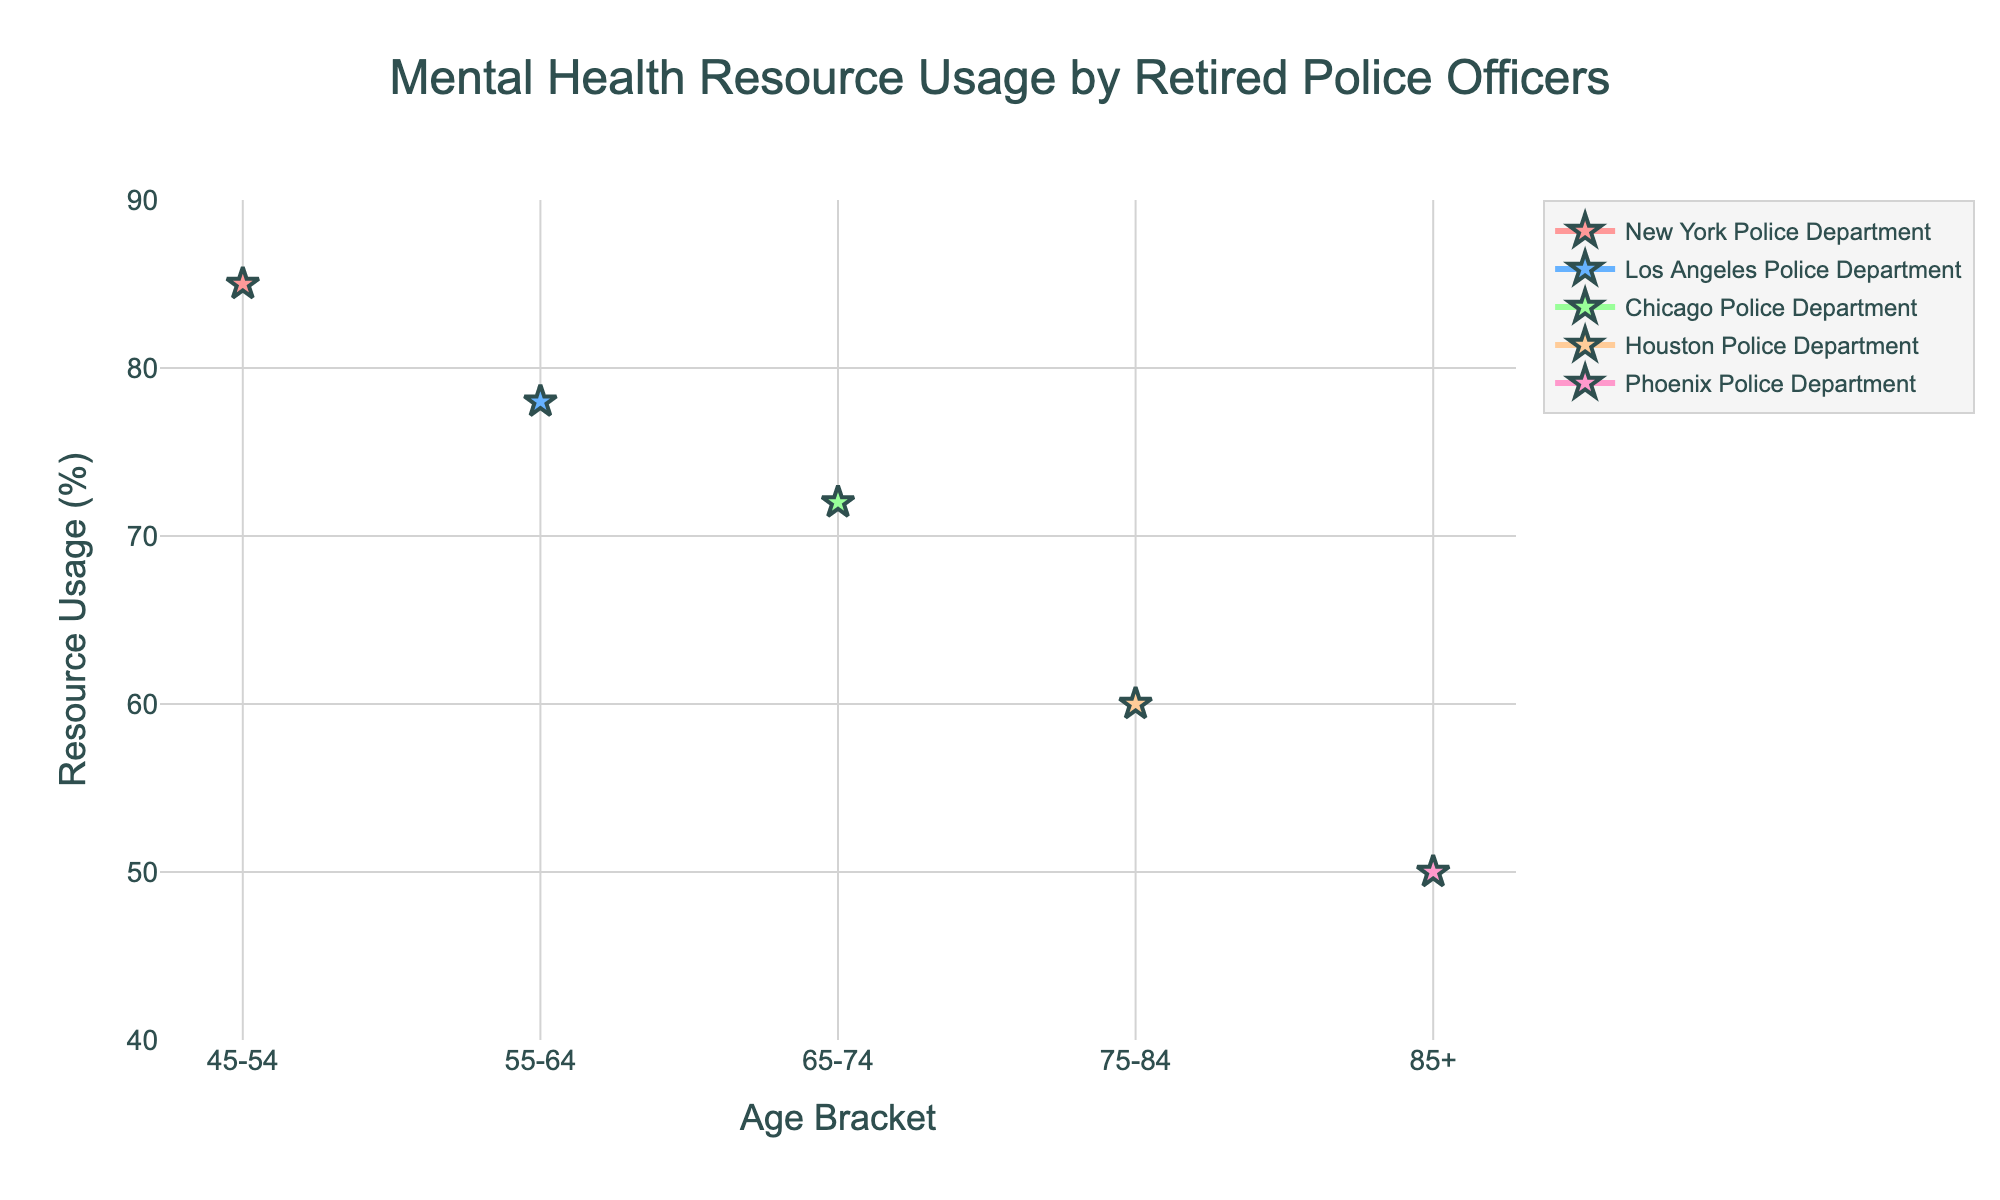How many unique departments are shown in the plot? There are five unique lines in the plot, each representing a different department. We can identify them by looking at the legend or the different colors and labels used on the plot: New York Police Department, Los Angeles Police Department, Chicago Police Department, Houston Police Department, Phoenix Police Department.
Answer: 5 What is the title of the plot? The title is displayed prominently at the top of the plot. It reads "Mental Health Resource Usage by Retired Police Officers".
Answer: Mental Health Resource Usage by Retired Police Officers Which age bracket has the highest resource usage percentage, and which department does it belong to? By examining the plot, we can see that the highest peak on the y-axis for Resource Usage (%) is for the age bracket 45-54, and the department listed is the New York Police Department.
Answer: 45-54, New York Police Department What is the resource usage percentage for officers aged 75-84 in the Houston Police Department? By locating the Houston Police Department's line and marker on the plot for the age bracket 75-84, the resource usage percentage is displayed at the point for that age bracket. The corresponding value is 60%.
Answer: 60% Which department shows a continuous decrease in resource usage as age increases? By analyzing the trends of each department's line, it is evident that the New York Police Department shows a consistent decrease in resource usage percentage as age brackets increase from 45-54 to 85+.
Answer: New York Police Department What is the difference in resource usage percentage between the age brackets 55-64 and 75-84 in the Los Angeles Police Department? First, locate the Los Angeles Police Department's line and find the resource usage percentages for age brackets 55-64 and 75-84, which are 78% and 60% respectively. Calculate the difference: 78% - 60% = 18%.
Answer: 18% What is the trend for resource usage percentage in the Phoenix Police Department as age increases? By examining the line representing the Phoenix Police Department, it can be observed that the resource usage percentage gradually decreases as the age brackets increase.
Answer: Decreasing How does the resource usage percentage in the 85+ age bracket compare between the New York Police Department and the Phoenix Police Department? Locate the points for the 85+ age bracket for both departments and compare their resource usage percentages. The New York Police Department is not present for this age bracket, but the Phoenix Police Department shows a resource usage of 50%. Therefore, there is no direct comparison possible since the New York Police Department does not have data for 85+.
Answer: New York Police Department: N/A, Phoenix Police Department: 50% Examine the overall shape of the Chicago Police Department's line. What can you infer about their resource usage across different age brackets? By tracing the Chicago Police Department's line, it can be seen that it starts at a higher usage in the 65-74 age bracket but shows a general downward trend. This indicates a higher resource usage in the middle age brackets and a decrease as age increases.
Answer: High at 65-74, then decreases What age bracket does the Los Angeles Police Department have their highest resource usage percentage? By following the line for the Los Angeles Police Department, it peaks at the 55-64 age bracket with a resource usage percentage of 78%.
Answer: 55-64 